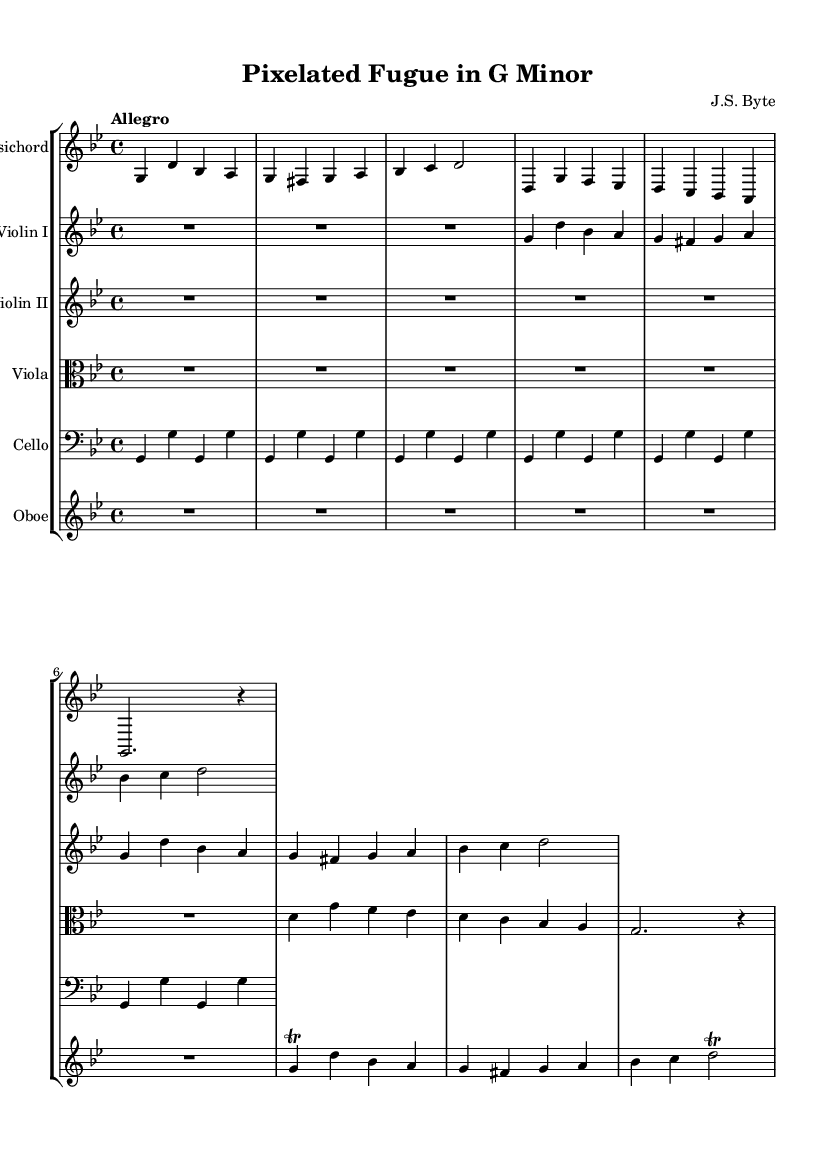What is the key signature of this music? The key signature is G minor, which features two flats (B flat and E flat). This can be determined by looking at the key signature at the beginning of the score, right after the clef.
Answer: G minor What is the time signature of this music? The time signature is 4/4, indicating that there are four beats in each measure and that a quarter note gets one beat. This is observed in the time signature marking at the beginning of the piece.
Answer: 4/4 What is the tempo marking of this music? The tempo marking is "Allegro," indicating a fast and lively pace. This can be found in the tempo indication positioned above the staff at the start of the piece.
Answer: Allegro How many instruments are represented in this orchestral piece? There are six instruments represented: Harpsichord, Violin I, Violin II, Viola, Cello, and Oboe. Each instrument has its own staff in the score, easily identifiable by the instrument names at the beginning of each staff.
Answer: Six Which instrument plays a trill in this music? The Oboe plays a trill, as indicated by the trill marking next to certain notes in the Oboe part. This shows that the performer should alternate quickly between the specified note and the note above it.
Answer: Oboe What is the rhythmic value of the first note in the Harpsichord part? The first note in the Harpsichord part is a quarter note. This is inferred from the appearance of the note in musical notation, which shows it occupies one quarter of a measure.
Answer: Quarter note What is the melodic range of the Violin I part? The melodic range of the Violin I part spans from G to D, which corresponds with the notation on the staff; the lowest note is G (in the second octave) and the highest note is D (in the third octave).
Answer: G to D 